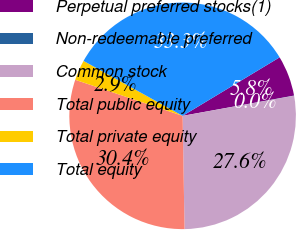Convert chart. <chart><loc_0><loc_0><loc_500><loc_500><pie_chart><fcel>Perpetual preferred stocks(1)<fcel>Non-redeemable preferred<fcel>Common stock<fcel>Total public equity<fcel>Total private equity<fcel>Total equity<nl><fcel>5.77%<fcel>0.03%<fcel>27.56%<fcel>30.43%<fcel>2.9%<fcel>33.3%<nl></chart> 